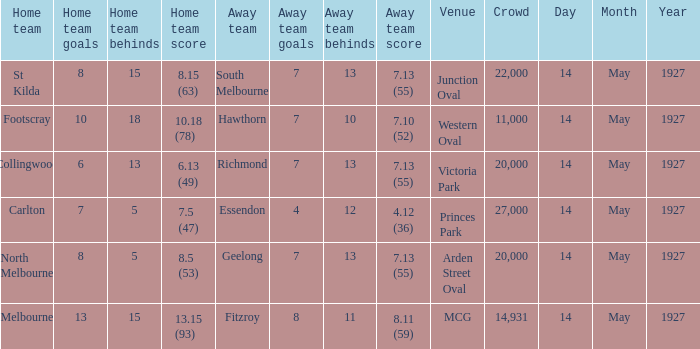Which site featured a home team with a score of 1 MCG. 